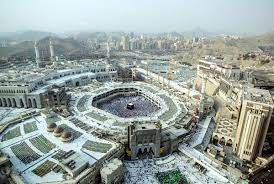What do you think is going on in this snapshot? The image provides a stunning aerial perspective of the Great Mosque of Mecca, the holiest site in Islam. This vast, white architectural marvel is distinguished by its numerous minarets and domes reaching skyward. At the heart of the mosque's vast central courtyard is the Kaaba, a black cube-shaped structure that is the focal point for millions of Muslims worldwide during their prayers. Encircling the mosque are modern high-rise buildings forming the city's skyline, testament to Mecca's urban development. In the background, rugged mountains loom, contrasting with the urban environment and adding a touch of natural beauty to the scene. This high-angle shot captures the grandeur of the Great Mosque and emphasizes its spiritual and architectural significance amidst the bustling city of Mecca. 